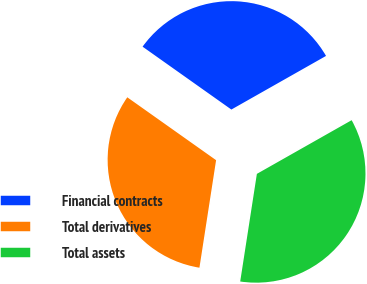Convert chart. <chart><loc_0><loc_0><loc_500><loc_500><pie_chart><fcel>Financial contracts<fcel>Total derivatives<fcel>Total assets<nl><fcel>31.99%<fcel>32.36%<fcel>35.65%<nl></chart> 